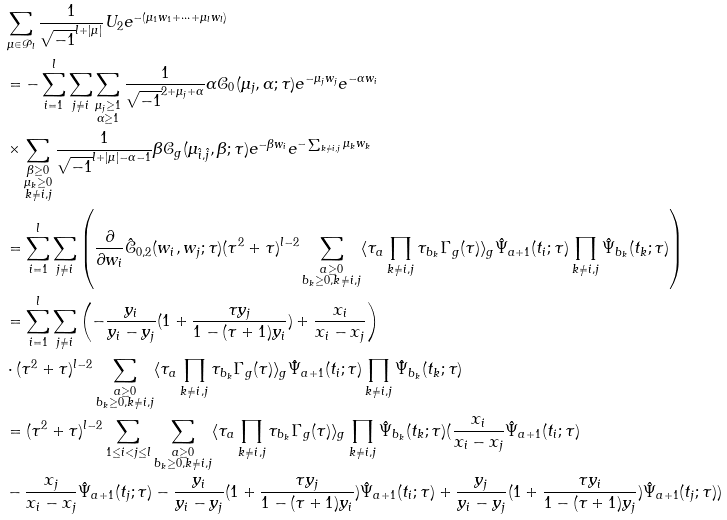<formula> <loc_0><loc_0><loc_500><loc_500>& \sum _ { \mu \in \mathcal { P } _ { l } } \frac { 1 } { \sqrt { - 1 } ^ { l + | \mu | } } U _ { 2 } e ^ { - ( \mu _ { 1 } w _ { 1 } + \cdots + \mu _ { l } w _ { l } ) } \\ & = - \sum _ { i = 1 } ^ { l } \sum _ { j \neq i } \sum _ { \substack { \mu _ { j } \geq 1 \\ \alpha \geq 1 } } \frac { 1 } { \sqrt { - 1 } ^ { 2 + \mu _ { j } + \alpha } } \alpha \mathcal { C } _ { 0 } ( \mu _ { j } , \alpha ; \tau ) e ^ { - \mu _ { j } w _ { j } } e ^ { - \alpha w _ { i } } \\ & \times \sum _ { \substack { \beta \geq 0 \\ \mu _ { k } \geq 0 \\ k \neq i , j } } \frac { 1 } { \sqrt { - 1 } ^ { l + | \mu | - \alpha - 1 } } \beta \mathcal { C } _ { g } ( \mu _ { \hat { i } , \hat { j } } , \beta ; \tau ) e ^ { - \beta w _ { i } } e ^ { - \sum _ { k \neq i , j } \mu _ { k } w _ { k } } \\ & = \sum _ { i = 1 } ^ { l } \sum _ { j \neq i } \left ( \frac { \partial } { \partial w _ { i } } \hat { \mathcal { C } } _ { 0 , 2 } ( w _ { i } , w _ { j } ; \tau ) ( \tau ^ { 2 } + \tau ) ^ { l - 2 } \sum _ { \substack { a \geq 0 \\ b _ { k } \geq 0 , k \neq i , j } } \langle \tau _ { a } \prod _ { k \neq i , j } \tau _ { b _ { k } } \Gamma _ { g } ( \tau ) \rangle _ { g } \hat { \Psi } _ { a + 1 } ( t _ { i } ; \tau ) \prod _ { k \neq i , j } \hat { \Psi } _ { b _ { k } } ( t _ { k } ; \tau ) \right ) \\ & = \sum _ { i = 1 } ^ { l } \sum _ { j \neq i } \left ( - \frac { y _ { i } } { y _ { i } - y _ { j } } ( 1 + \frac { \tau y _ { j } } { 1 - ( \tau + 1 ) y _ { i } } ) + \frac { x _ { i } } { x _ { i } - x _ { j } } \right ) \\ & \cdot ( \tau ^ { 2 } + \tau ) ^ { l - 2 } \sum _ { \substack { a \geq 0 \\ b _ { k } \geq 0 , k \neq i , j } } \langle \tau _ { a } \prod _ { k \neq i , j } \tau _ { b _ { k } } \Gamma _ { g } ( \tau ) \rangle _ { g } \hat { \Psi } _ { a + 1 } ( t _ { i } ; \tau ) \prod _ { k \neq i , j } \hat { \Psi } _ { b _ { k } } ( t _ { k } ; \tau ) \\ & = ( \tau ^ { 2 } + \tau ) ^ { l - 2 } \sum _ { 1 \leq i < j \leq l } \sum _ { \substack { a \geq 0 \\ b _ { k } \geq 0 , k \neq i , j } } \langle \tau _ { a } \prod _ { k \neq i , j } \tau _ { b _ { k } } \Gamma _ { g } ( \tau ) \rangle _ { g } \prod _ { k \neq i , j } \hat { \Psi } _ { b _ { k } } ( t _ { k } ; \tau ) ( \frac { x _ { i } } { x _ { i } - x _ { j } } \hat { \Psi } _ { a + 1 } ( t _ { i } ; \tau ) \\ & - \frac { x _ { j } } { x _ { i } - x _ { j } } \hat { \Psi } _ { a + 1 } ( t _ { j } ; \tau ) - \frac { y _ { i } } { y _ { i } - y _ { j } } ( 1 + \frac { \tau y _ { j } } { 1 - ( \tau + 1 ) y _ { i } } ) \hat { \Psi } _ { a + 1 } ( t _ { i } ; \tau ) + \frac { y _ { j } } { y _ { i } - y _ { j } } ( 1 + \frac { \tau y _ { i } } { 1 - ( \tau + 1 ) y _ { j } } ) \hat { \Psi } _ { a + 1 } ( t _ { j } ; \tau ) )</formula> 